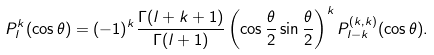<formula> <loc_0><loc_0><loc_500><loc_500>P _ { l } ^ { k } ( \cos \theta ) = ( - 1 ) ^ { k } \frac { \Gamma ( l + k + 1 ) } { \Gamma ( l + 1 ) } \left ( \cos \frac { \theta } { 2 } \sin \frac { \theta } { 2 } \right ) ^ { k } P _ { l - k } ^ { \left ( k , k \right ) } ( \cos \theta ) .</formula> 